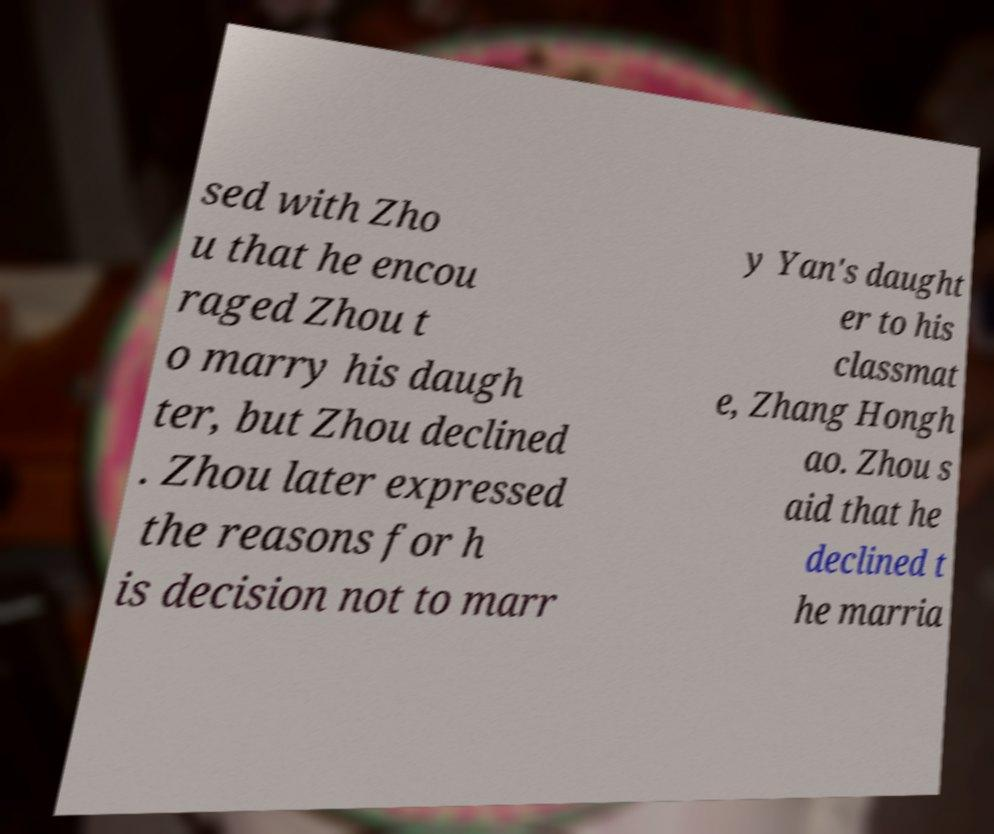For documentation purposes, I need the text within this image transcribed. Could you provide that? sed with Zho u that he encou raged Zhou t o marry his daugh ter, but Zhou declined . Zhou later expressed the reasons for h is decision not to marr y Yan's daught er to his classmat e, Zhang Hongh ao. Zhou s aid that he declined t he marria 